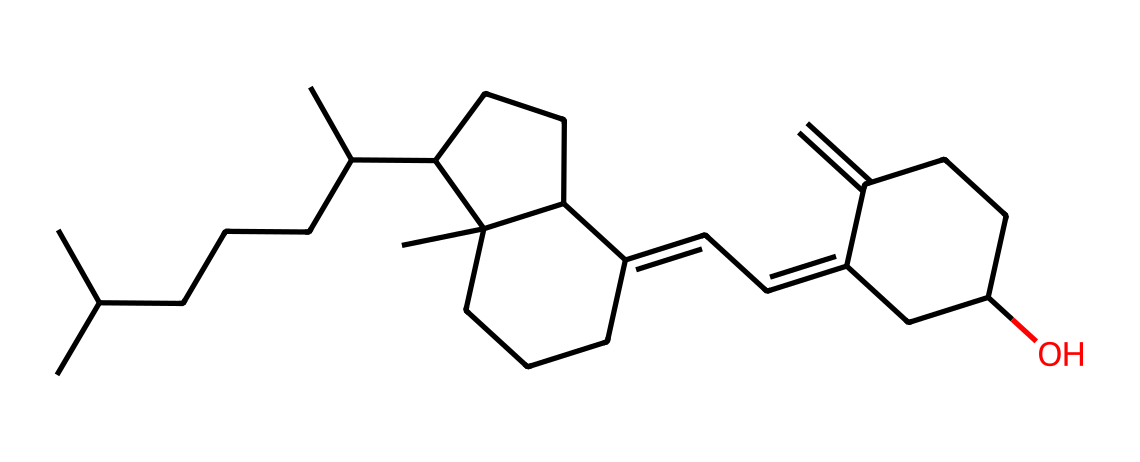What is the base structure of this vitamin? The chemical structure corresponds to cholecalciferol, a form of vitamin D3. This can be identified by recognizing the characteristic steroid-like core and side chain configuration typical of vitamin D molecules.
Answer: cholecalciferol How many carbon atoms are in the structure? By counting the 'C' symbols in the SMILES representation, one can determine there are 27 carbon atoms in this vitamin D structure.
Answer: 27 What type of functional group is present in this molecule? The presence of a hydroxyl group (-OH) indicates that this vitamin contains a functional group characteristic of its classification as a sterol. This can be observed from the Oxygen atom attached to a carbon at the end of the structure.
Answer: hydroxyl What is the molecular formula of this compound? By deriving the chemical formula from the SMILES representation, which consists of 27 carbons, 46 hydrogens, and 1 oxygen, the molecular formula is deduced as C27H46O.
Answer: C27H46O Is this vitamin fat-soluble or water-soluble? The presence of a large hydrocarbon structure, along with the hydroxyl group, suggests that vitamin D is fat-soluble. This is characteristic of vitamins that can dissolve in fats and oils.
Answer: fat-soluble What characteristic edge does the molecule exhibit due to its structure? The cyclic structures and the presence of double bonds create rigid planar regions, which contribute to its biological activity and affinity for binding to proteins. This can affect its function in the body.
Answer: rigid edges How does sunlight affect the synthesis of this vitamin? Sunlight catalyzes the conversion of a precursor in the skin into vitamin D3, facilitated by the energy that breaks specific bonds, thus allowing the rearrangement into the characteristic structure of vitamin D.
Answer: synthesis catalyzed by sunlight 